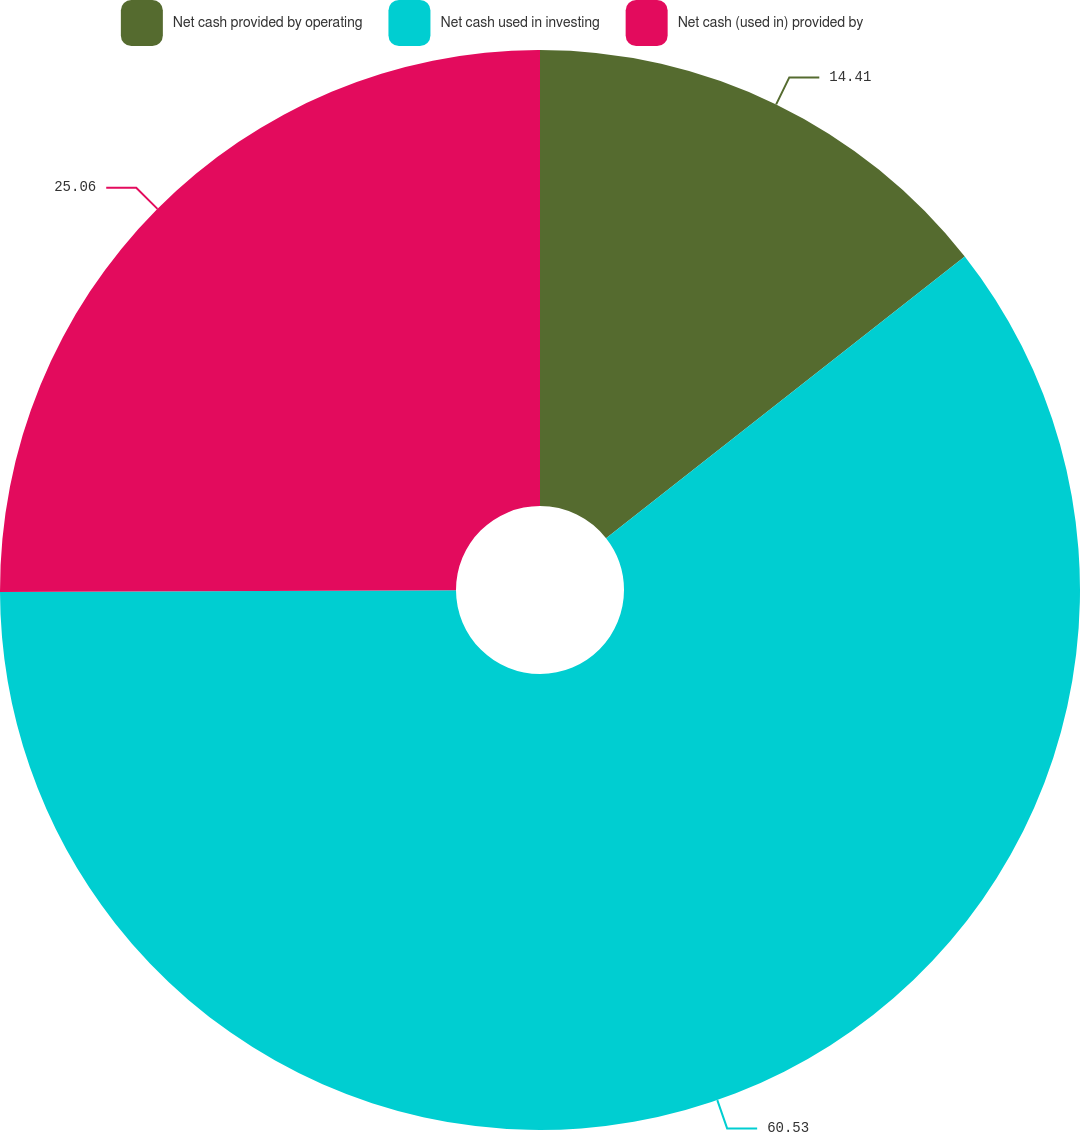Convert chart to OTSL. <chart><loc_0><loc_0><loc_500><loc_500><pie_chart><fcel>Net cash provided by operating<fcel>Net cash used in investing<fcel>Net cash (used in) provided by<nl><fcel>14.41%<fcel>60.54%<fcel>25.06%<nl></chart> 